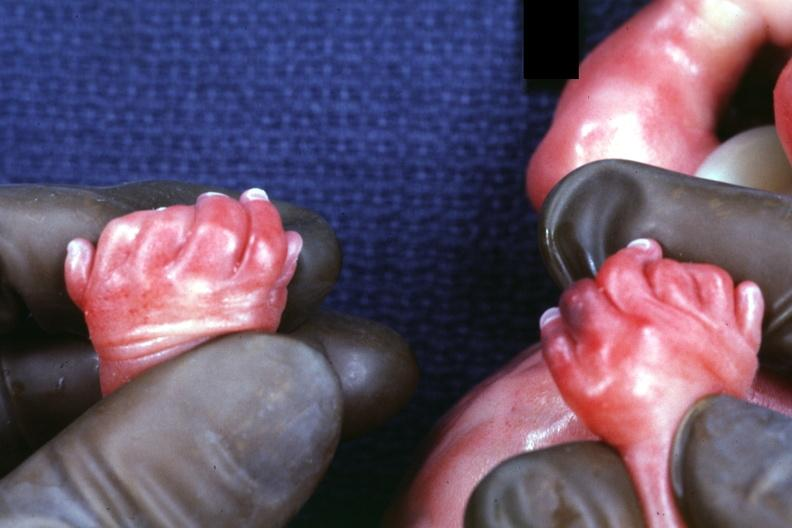what does this image show?
Answer the question using a single word or phrase. Child has polycystic disease 